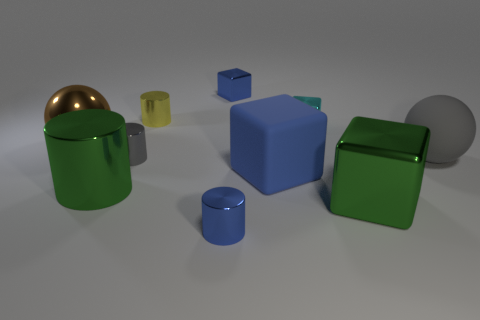Is the number of brown spheres that are right of the gray ball greater than the number of large brown metal balls? Actually, there are no brown spheres located to the right of the gray sphere in the image. 